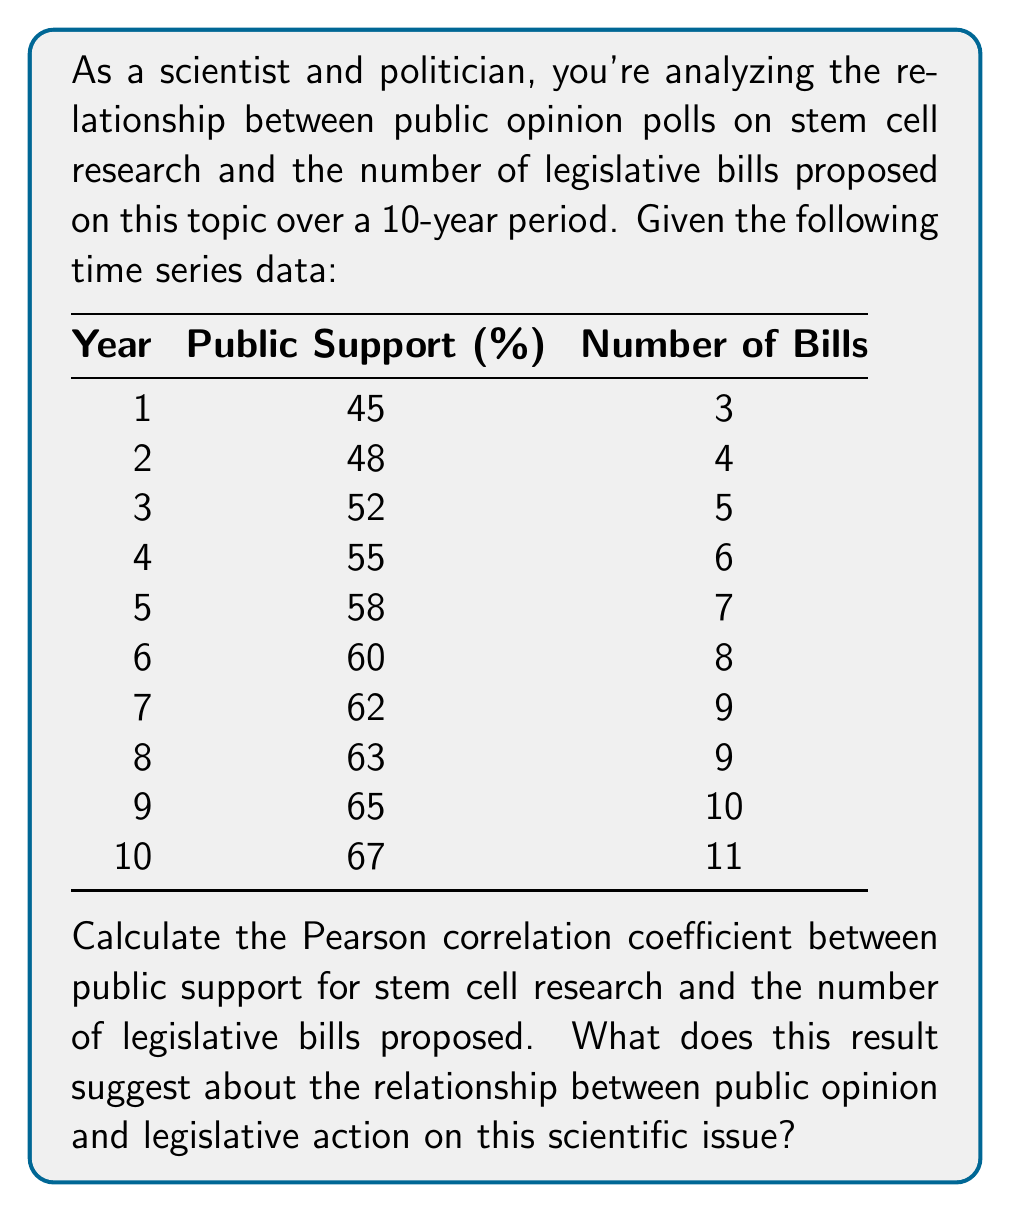Solve this math problem. To calculate the Pearson correlation coefficient, we'll use the formula:

$$ r = \frac{\sum_{i=1}^{n} (x_i - \bar{x})(y_i - \bar{y})}{\sqrt{\sum_{i=1}^{n} (x_i - \bar{x})^2} \sqrt{\sum_{i=1}^{n} (y_i - \bar{y})^2}} $$

Where:
$x_i$ = Public Support values
$y_i$ = Number of Bills
$\bar{x}$ = Mean of Public Support
$\bar{y}$ = Mean of Number of Bills
$n$ = Number of data points (10 in this case)

Step 1: Calculate means
$\bar{x} = \frac{45 + 48 + 52 + 55 + 58 + 60 + 62 + 63 + 65 + 67}{10} = 57.5$
$\bar{y} = \frac{3 + 4 + 5 + 6 + 7 + 8 + 9 + 9 + 10 + 11}{10} = 7.2$

Step 2: Calculate the numerator $\sum_{i=1}^{n} (x_i - \bar{x})(y_i - \bar{y})$
$(-12.5 \times -4.2) + (-9.5 \times -3.2) + ... + (9.5 \times 3.8) = 224.5$

Step 3: Calculate $\sum_{i=1}^{n} (x_i - \bar{x})^2$
$(-12.5)^2 + (-9.5)^2 + ... + (9.5)^2 = 506.25$

Step 4: Calculate $\sum_{i=1}^{n} (y_i - \bar{y})^2$
$(-4.2)^2 + (-3.2)^2 + ... + (3.8)^2 = 59.6$

Step 5: Calculate the denominator
$\sqrt{506.25} \times \sqrt{59.6} = 22.5 \times 7.72 = 173.7$

Step 6: Calculate the correlation coefficient
$r = \frac{224.5}{173.7} \approx 0.9928$

This strong positive correlation (very close to 1) suggests that there is a strong linear relationship between public support for stem cell research and the number of legislative bills proposed on the topic. As public support increases, the number of bills proposed also tends to increase proportionally.
Answer: The Pearson correlation coefficient is approximately 0.9928. This indicates a very strong positive correlation between public support for stem cell research and the number of legislative bills proposed, suggesting that public opinion has a significant influence on legislative action regarding this scientific issue. 